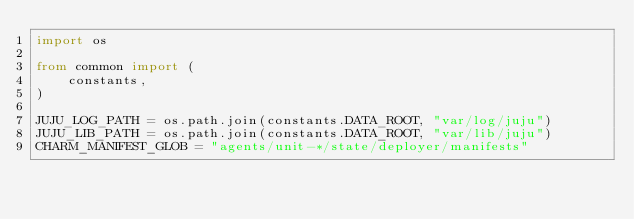Convert code to text. <code><loc_0><loc_0><loc_500><loc_500><_Python_>import os

from common import (
    constants,
)

JUJU_LOG_PATH = os.path.join(constants.DATA_ROOT, "var/log/juju")
JUJU_LIB_PATH = os.path.join(constants.DATA_ROOT, "var/lib/juju")
CHARM_MANIFEST_GLOB = "agents/unit-*/state/deployer/manifests"
</code> 